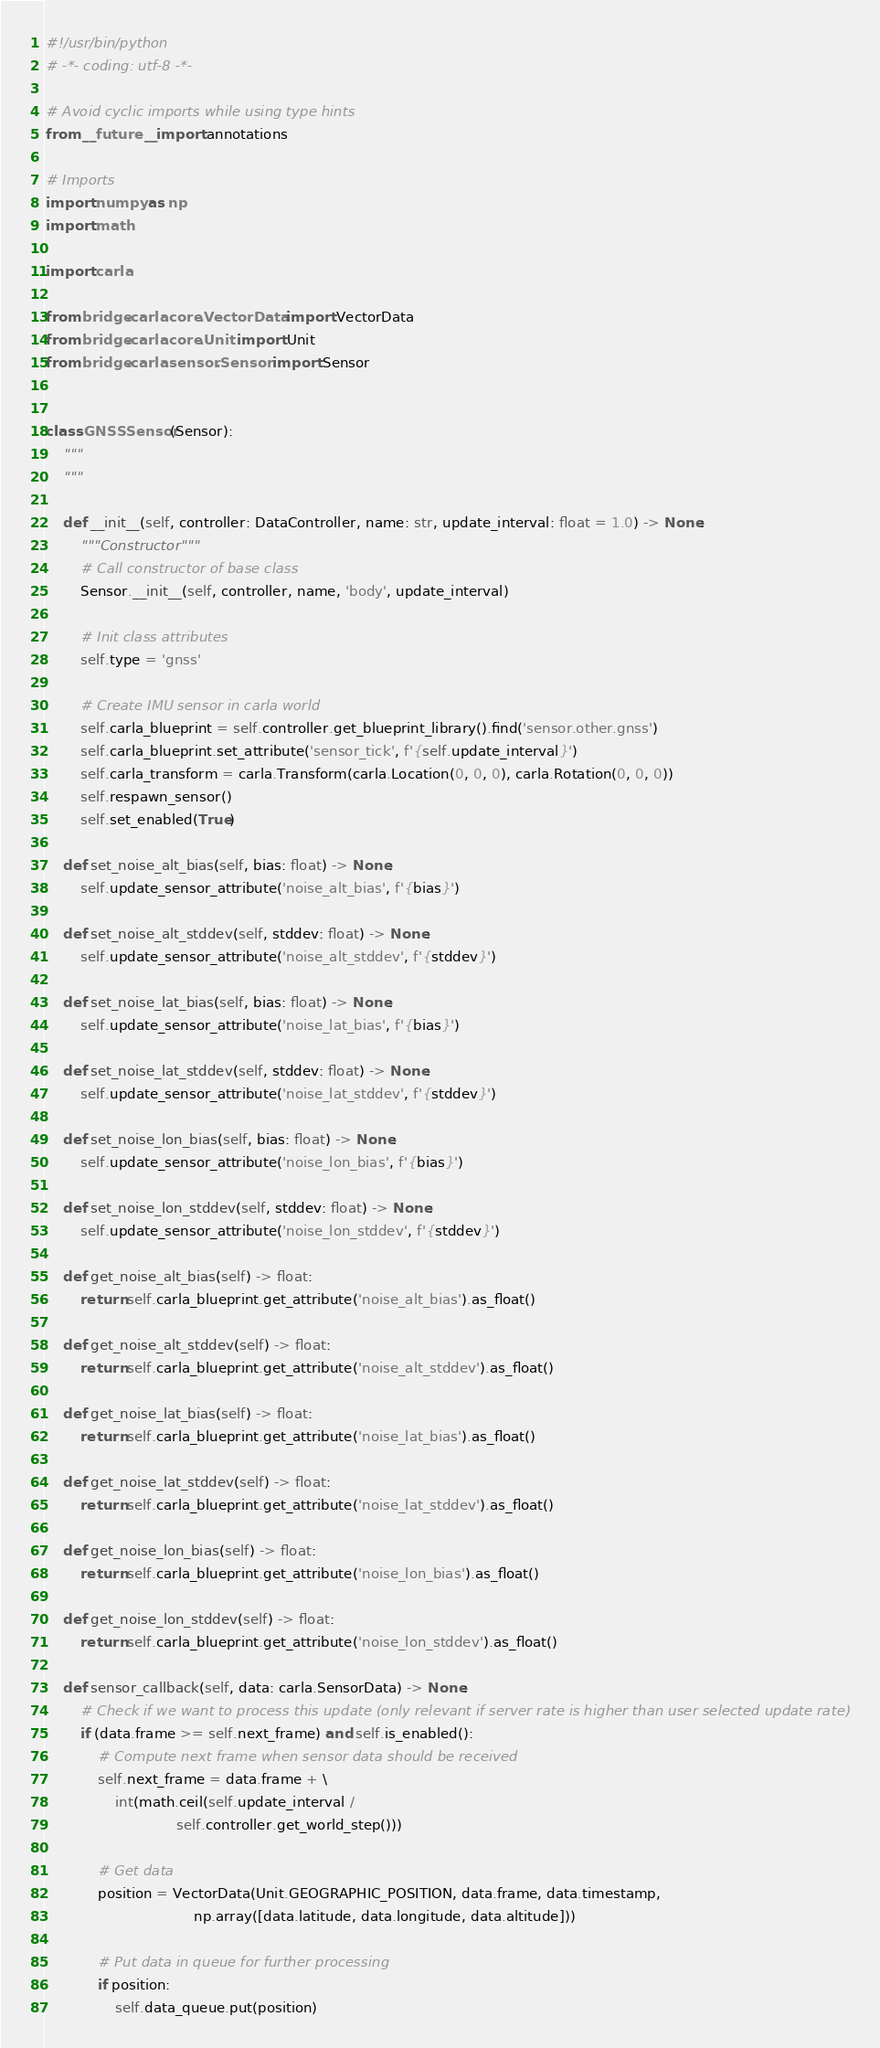Convert code to text. <code><loc_0><loc_0><loc_500><loc_500><_Python_>#!/usr/bin/python
# -*- coding: utf-8 -*-

# Avoid cyclic imports while using type hints
from __future__ import annotations

# Imports
import numpy as np
import math

import carla

from bridge.carla.core.VectorData import VectorData
from bridge.carla.core.Unit import Unit
from bridge.carla.sensor.Sensor import Sensor


class GNSSSensor(Sensor):
    """
    """

    def __init__(self, controller: DataController, name: str, update_interval: float = 1.0) -> None:
        """Constructor"""
        # Call constructor of base class
        Sensor.__init__(self, controller, name, 'body', update_interval)

        # Init class attributes
        self.type = 'gnss'

        # Create IMU sensor in carla world
        self.carla_blueprint = self.controller.get_blueprint_library().find('sensor.other.gnss')
        self.carla_blueprint.set_attribute('sensor_tick', f'{self.update_interval}')
        self.carla_transform = carla.Transform(carla.Location(0, 0, 0), carla.Rotation(0, 0, 0))
        self.respawn_sensor()
        self.set_enabled(True)

    def set_noise_alt_bias(self, bias: float) -> None:
        self.update_sensor_attribute('noise_alt_bias', f'{bias}')

    def set_noise_alt_stddev(self, stddev: float) -> None:
        self.update_sensor_attribute('noise_alt_stddev', f'{stddev}')

    def set_noise_lat_bias(self, bias: float) -> None:
        self.update_sensor_attribute('noise_lat_bias', f'{bias}')

    def set_noise_lat_stddev(self, stddev: float) -> None:
        self.update_sensor_attribute('noise_lat_stddev', f'{stddev}')

    def set_noise_lon_bias(self, bias: float) -> None:
        self.update_sensor_attribute('noise_lon_bias', f'{bias}')

    def set_noise_lon_stddev(self, stddev: float) -> None:
        self.update_sensor_attribute('noise_lon_stddev', f'{stddev}')

    def get_noise_alt_bias(self) -> float:
        return self.carla_blueprint.get_attribute('noise_alt_bias').as_float()

    def get_noise_alt_stddev(self) -> float:
        return self.carla_blueprint.get_attribute('noise_alt_stddev').as_float()

    def get_noise_lat_bias(self) -> float:
        return self.carla_blueprint.get_attribute('noise_lat_bias').as_float()

    def get_noise_lat_stddev(self) -> float:
        return self.carla_blueprint.get_attribute('noise_lat_stddev').as_float()

    def get_noise_lon_bias(self) -> float:
        return self.carla_blueprint.get_attribute('noise_lon_bias').as_float()

    def get_noise_lon_stddev(self) -> float:
        return self.carla_blueprint.get_attribute('noise_lon_stddev').as_float()

    def sensor_callback(self, data: carla.SensorData) -> None:
        # Check if we want to process this update (only relevant if server rate is higher than user selected update rate)
        if (data.frame >= self.next_frame) and self.is_enabled():
            # Compute next frame when sensor data should be received
            self.next_frame = data.frame + \
                int(math.ceil(self.update_interval /
                              self.controller.get_world_step()))

            # Get data
            position = VectorData(Unit.GEOGRAPHIC_POSITION, data.frame, data.timestamp,
                                  np.array([data.latitude, data.longitude, data.altitude]))

            # Put data in queue for further processing
            if position:
                self.data_queue.put(position)
</code> 